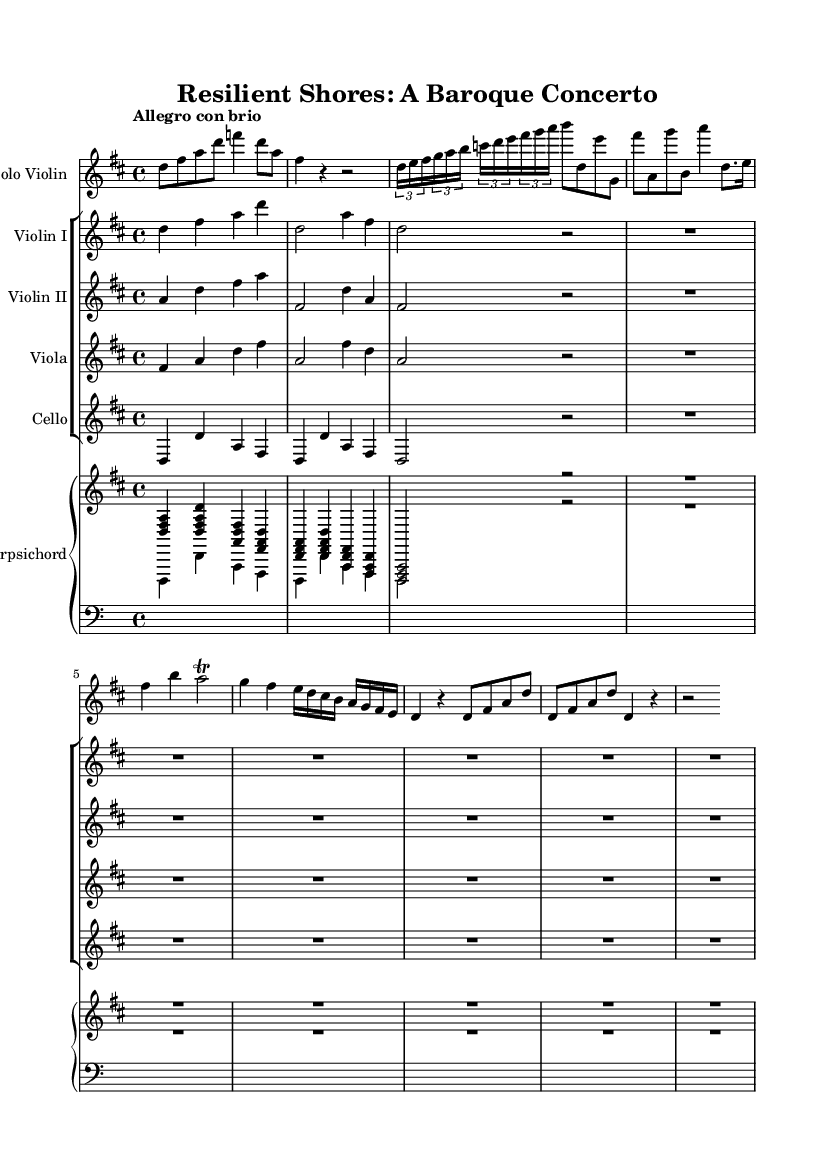What is the key signature of this music? The key signature is D major, which has two sharps (F# and C#). This can be identified in the beginning of the staff where the sharps are indicated.
Answer: D major What is the time signature? The time signature is 4/4, which indicates four beats in each measure and that a quarter note receives one beat. This is noted at the beginning of the score next to the key signature.
Answer: 4/4 What is the tempo marking? The tempo marking is "Allegro con brio," indicating a fast and lively speed. It is specified at the beginning of the score, showing how the piece should be played.
Answer: Allegro con brio How many measures are in the violin solo section? The violin solo section contains eight measures. By counting the measures in the provided section of the music for the solo violin, we can confirm this total.
Answer: eight Which instrument has the highest pitch range in this piece? The solo violin typically has the highest pitch range compared to the other instruments, as it's notated an octave higher than violas and cellos. By visually assessing the clefs and notation, this can be determined.
Answer: Solo Violin How does the violin II part relate to the violin I part? The violin II part provides harmonic support to the violin I part, which leads the melody. This relationship is established through the harmonization of the accompanying parts, which complements the melody played by the first violin.
Answer: Harmonic support What is the primary texture of the overall composition? The primary texture is homophonic, as the melody is supported by harmonic accompaniment, allowing the solo line to stand out clearly against the backdrop of the ensemble. This is evident in how the different parts are structured around the main theme.
Answer: Homophonic 